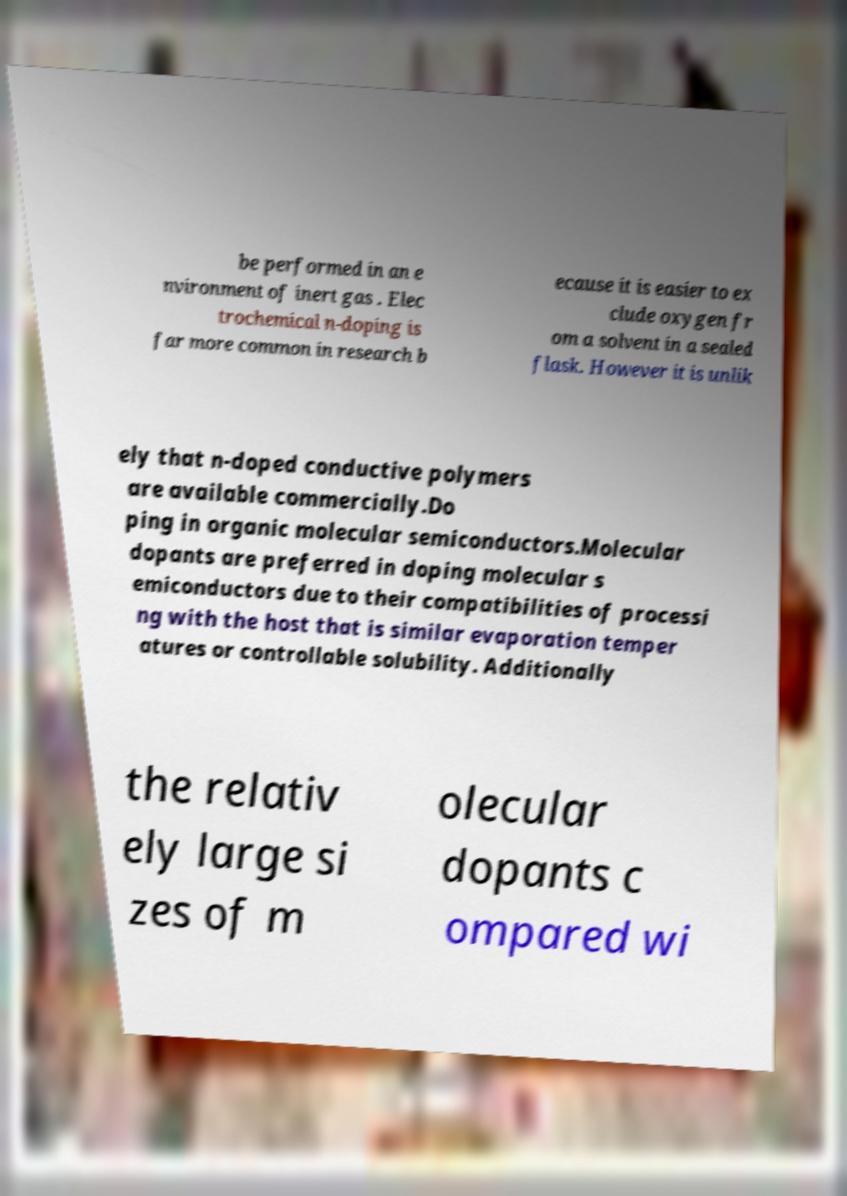Can you accurately transcribe the text from the provided image for me? be performed in an e nvironment of inert gas . Elec trochemical n-doping is far more common in research b ecause it is easier to ex clude oxygen fr om a solvent in a sealed flask. However it is unlik ely that n-doped conductive polymers are available commercially.Do ping in organic molecular semiconductors.Molecular dopants are preferred in doping molecular s emiconductors due to their compatibilities of processi ng with the host that is similar evaporation temper atures or controllable solubility. Additionally the relativ ely large si zes of m olecular dopants c ompared wi 